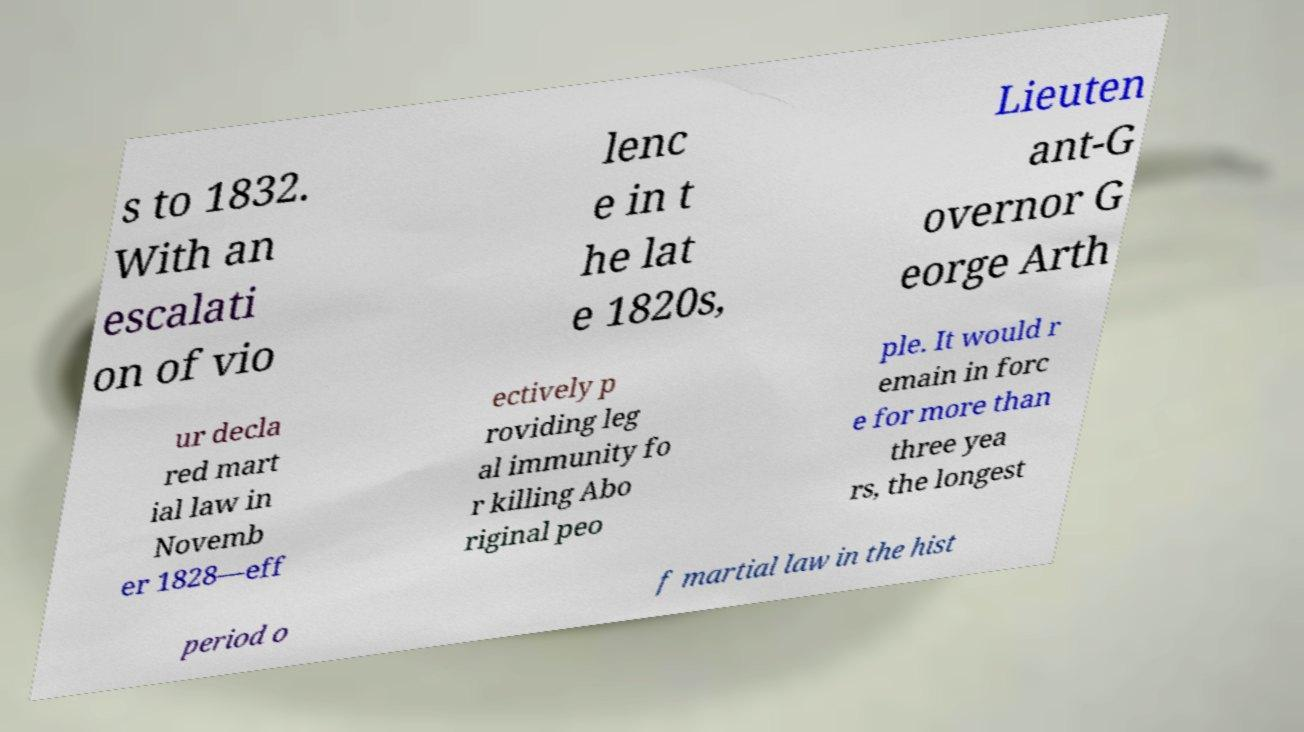What messages or text are displayed in this image? I need them in a readable, typed format. s to 1832. With an escalati on of vio lenc e in t he lat e 1820s, Lieuten ant-G overnor G eorge Arth ur decla red mart ial law in Novemb er 1828—eff ectively p roviding leg al immunity fo r killing Abo riginal peo ple. It would r emain in forc e for more than three yea rs, the longest period o f martial law in the hist 